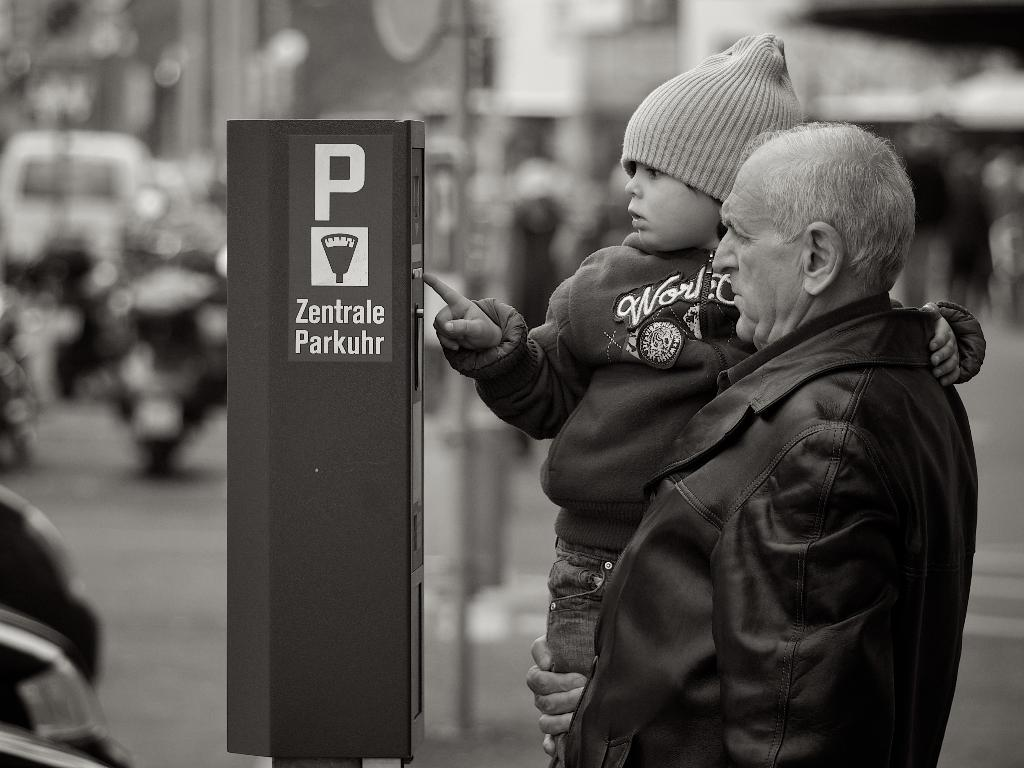<image>
Describe the image concisely. A child presses a button an a device on the street with a P on the side. 